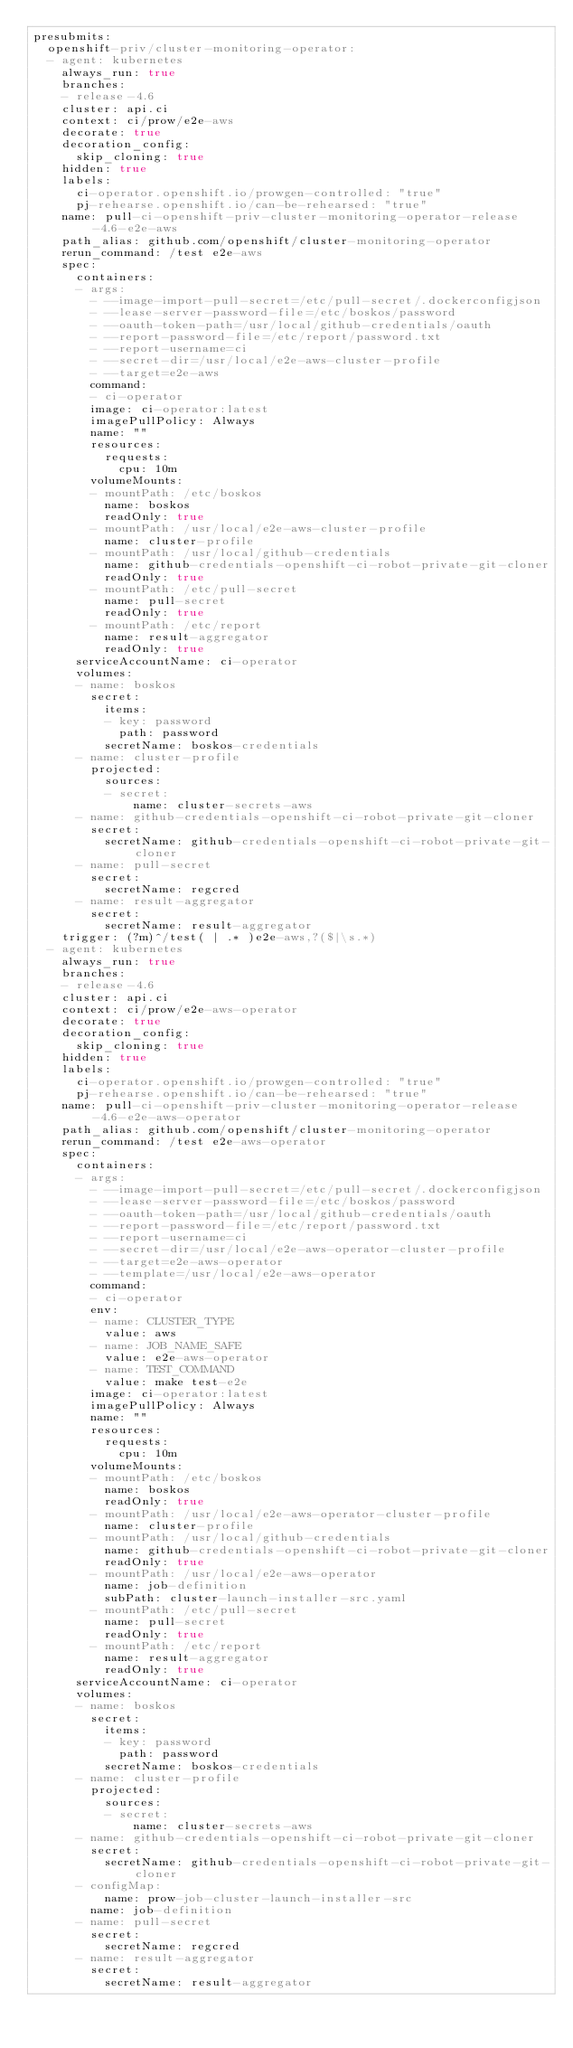<code> <loc_0><loc_0><loc_500><loc_500><_YAML_>presubmits:
  openshift-priv/cluster-monitoring-operator:
  - agent: kubernetes
    always_run: true
    branches:
    - release-4.6
    cluster: api.ci
    context: ci/prow/e2e-aws
    decorate: true
    decoration_config:
      skip_cloning: true
    hidden: true
    labels:
      ci-operator.openshift.io/prowgen-controlled: "true"
      pj-rehearse.openshift.io/can-be-rehearsed: "true"
    name: pull-ci-openshift-priv-cluster-monitoring-operator-release-4.6-e2e-aws
    path_alias: github.com/openshift/cluster-monitoring-operator
    rerun_command: /test e2e-aws
    spec:
      containers:
      - args:
        - --image-import-pull-secret=/etc/pull-secret/.dockerconfigjson
        - --lease-server-password-file=/etc/boskos/password
        - --oauth-token-path=/usr/local/github-credentials/oauth
        - --report-password-file=/etc/report/password.txt
        - --report-username=ci
        - --secret-dir=/usr/local/e2e-aws-cluster-profile
        - --target=e2e-aws
        command:
        - ci-operator
        image: ci-operator:latest
        imagePullPolicy: Always
        name: ""
        resources:
          requests:
            cpu: 10m
        volumeMounts:
        - mountPath: /etc/boskos
          name: boskos
          readOnly: true
        - mountPath: /usr/local/e2e-aws-cluster-profile
          name: cluster-profile
        - mountPath: /usr/local/github-credentials
          name: github-credentials-openshift-ci-robot-private-git-cloner
          readOnly: true
        - mountPath: /etc/pull-secret
          name: pull-secret
          readOnly: true
        - mountPath: /etc/report
          name: result-aggregator
          readOnly: true
      serviceAccountName: ci-operator
      volumes:
      - name: boskos
        secret:
          items:
          - key: password
            path: password
          secretName: boskos-credentials
      - name: cluster-profile
        projected:
          sources:
          - secret:
              name: cluster-secrets-aws
      - name: github-credentials-openshift-ci-robot-private-git-cloner
        secret:
          secretName: github-credentials-openshift-ci-robot-private-git-cloner
      - name: pull-secret
        secret:
          secretName: regcred
      - name: result-aggregator
        secret:
          secretName: result-aggregator
    trigger: (?m)^/test( | .* )e2e-aws,?($|\s.*)
  - agent: kubernetes
    always_run: true
    branches:
    - release-4.6
    cluster: api.ci
    context: ci/prow/e2e-aws-operator
    decorate: true
    decoration_config:
      skip_cloning: true
    hidden: true
    labels:
      ci-operator.openshift.io/prowgen-controlled: "true"
      pj-rehearse.openshift.io/can-be-rehearsed: "true"
    name: pull-ci-openshift-priv-cluster-monitoring-operator-release-4.6-e2e-aws-operator
    path_alias: github.com/openshift/cluster-monitoring-operator
    rerun_command: /test e2e-aws-operator
    spec:
      containers:
      - args:
        - --image-import-pull-secret=/etc/pull-secret/.dockerconfigjson
        - --lease-server-password-file=/etc/boskos/password
        - --oauth-token-path=/usr/local/github-credentials/oauth
        - --report-password-file=/etc/report/password.txt
        - --report-username=ci
        - --secret-dir=/usr/local/e2e-aws-operator-cluster-profile
        - --target=e2e-aws-operator
        - --template=/usr/local/e2e-aws-operator
        command:
        - ci-operator
        env:
        - name: CLUSTER_TYPE
          value: aws
        - name: JOB_NAME_SAFE
          value: e2e-aws-operator
        - name: TEST_COMMAND
          value: make test-e2e
        image: ci-operator:latest
        imagePullPolicy: Always
        name: ""
        resources:
          requests:
            cpu: 10m
        volumeMounts:
        - mountPath: /etc/boskos
          name: boskos
          readOnly: true
        - mountPath: /usr/local/e2e-aws-operator-cluster-profile
          name: cluster-profile
        - mountPath: /usr/local/github-credentials
          name: github-credentials-openshift-ci-robot-private-git-cloner
          readOnly: true
        - mountPath: /usr/local/e2e-aws-operator
          name: job-definition
          subPath: cluster-launch-installer-src.yaml
        - mountPath: /etc/pull-secret
          name: pull-secret
          readOnly: true
        - mountPath: /etc/report
          name: result-aggregator
          readOnly: true
      serviceAccountName: ci-operator
      volumes:
      - name: boskos
        secret:
          items:
          - key: password
            path: password
          secretName: boskos-credentials
      - name: cluster-profile
        projected:
          sources:
          - secret:
              name: cluster-secrets-aws
      - name: github-credentials-openshift-ci-robot-private-git-cloner
        secret:
          secretName: github-credentials-openshift-ci-robot-private-git-cloner
      - configMap:
          name: prow-job-cluster-launch-installer-src
        name: job-definition
      - name: pull-secret
        secret:
          secretName: regcred
      - name: result-aggregator
        secret:
          secretName: result-aggregator</code> 